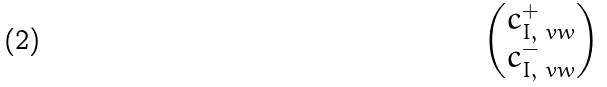Convert formula to latex. <formula><loc_0><loc_0><loc_500><loc_500>\begin{pmatrix} c _ { I , \ v w } ^ { + } \\ c _ { I , \ v w } ^ { - } \\ \end{pmatrix}</formula> 